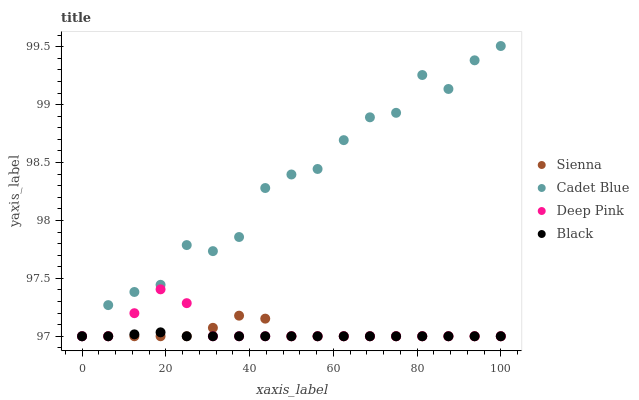Does Black have the minimum area under the curve?
Answer yes or no. Yes. Does Cadet Blue have the maximum area under the curve?
Answer yes or no. Yes. Does Cadet Blue have the minimum area under the curve?
Answer yes or no. No. Does Black have the maximum area under the curve?
Answer yes or no. No. Is Black the smoothest?
Answer yes or no. Yes. Is Cadet Blue the roughest?
Answer yes or no. Yes. Is Cadet Blue the smoothest?
Answer yes or no. No. Is Black the roughest?
Answer yes or no. No. Does Sienna have the lowest value?
Answer yes or no. Yes. Does Cadet Blue have the highest value?
Answer yes or no. Yes. Does Black have the highest value?
Answer yes or no. No. Does Sienna intersect Black?
Answer yes or no. Yes. Is Sienna less than Black?
Answer yes or no. No. Is Sienna greater than Black?
Answer yes or no. No. 